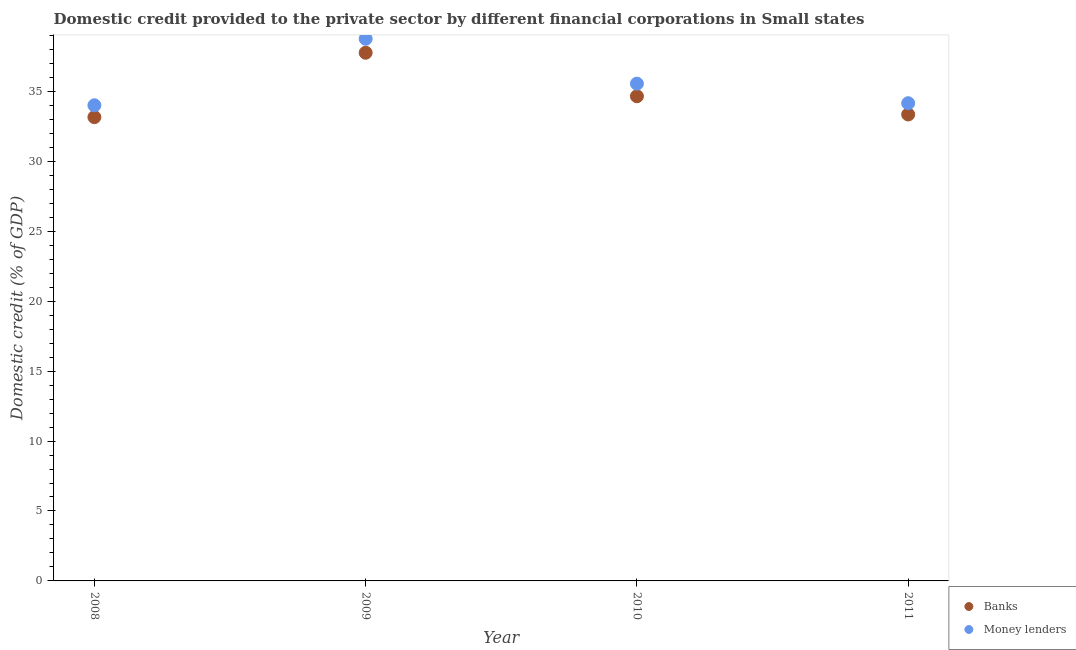How many different coloured dotlines are there?
Provide a succinct answer. 2. What is the domestic credit provided by money lenders in 2008?
Your answer should be compact. 34.01. Across all years, what is the maximum domestic credit provided by banks?
Offer a terse response. 37.76. Across all years, what is the minimum domestic credit provided by banks?
Ensure brevity in your answer.  33.16. In which year was the domestic credit provided by banks maximum?
Your answer should be compact. 2009. What is the total domestic credit provided by money lenders in the graph?
Give a very brief answer. 142.47. What is the difference between the domestic credit provided by money lenders in 2010 and that in 2011?
Provide a short and direct response. 1.4. What is the difference between the domestic credit provided by banks in 2010 and the domestic credit provided by money lenders in 2009?
Give a very brief answer. -4.11. What is the average domestic credit provided by money lenders per year?
Your answer should be compact. 35.62. In the year 2009, what is the difference between the domestic credit provided by money lenders and domestic credit provided by banks?
Your response must be concise. 1. What is the ratio of the domestic credit provided by money lenders in 2010 to that in 2011?
Make the answer very short. 1.04. Is the domestic credit provided by banks in 2008 less than that in 2009?
Make the answer very short. Yes. Is the difference between the domestic credit provided by money lenders in 2009 and 2010 greater than the difference between the domestic credit provided by banks in 2009 and 2010?
Make the answer very short. Yes. What is the difference between the highest and the second highest domestic credit provided by banks?
Offer a very short reply. 3.11. What is the difference between the highest and the lowest domestic credit provided by banks?
Your response must be concise. 4.6. In how many years, is the domestic credit provided by money lenders greater than the average domestic credit provided by money lenders taken over all years?
Offer a very short reply. 1. Is the sum of the domestic credit provided by money lenders in 2008 and 2009 greater than the maximum domestic credit provided by banks across all years?
Your answer should be very brief. Yes. Does the domestic credit provided by money lenders monotonically increase over the years?
Your answer should be compact. No. Is the domestic credit provided by banks strictly less than the domestic credit provided by money lenders over the years?
Provide a succinct answer. Yes. How many dotlines are there?
Your response must be concise. 2. How many years are there in the graph?
Keep it short and to the point. 4. What is the difference between two consecutive major ticks on the Y-axis?
Keep it short and to the point. 5. Are the values on the major ticks of Y-axis written in scientific E-notation?
Give a very brief answer. No. Does the graph contain any zero values?
Provide a succinct answer. No. Does the graph contain grids?
Give a very brief answer. No. How many legend labels are there?
Your answer should be very brief. 2. What is the title of the graph?
Provide a short and direct response. Domestic credit provided to the private sector by different financial corporations in Small states. Does "Forest" appear as one of the legend labels in the graph?
Ensure brevity in your answer.  No. What is the label or title of the Y-axis?
Provide a succinct answer. Domestic credit (% of GDP). What is the Domestic credit (% of GDP) in Banks in 2008?
Keep it short and to the point. 33.16. What is the Domestic credit (% of GDP) of Money lenders in 2008?
Make the answer very short. 34.01. What is the Domestic credit (% of GDP) in Banks in 2009?
Your answer should be compact. 37.76. What is the Domestic credit (% of GDP) in Money lenders in 2009?
Make the answer very short. 38.76. What is the Domestic credit (% of GDP) in Banks in 2010?
Offer a terse response. 34.65. What is the Domestic credit (% of GDP) in Money lenders in 2010?
Offer a very short reply. 35.55. What is the Domestic credit (% of GDP) in Banks in 2011?
Your answer should be compact. 33.35. What is the Domestic credit (% of GDP) in Money lenders in 2011?
Keep it short and to the point. 34.15. Across all years, what is the maximum Domestic credit (% of GDP) of Banks?
Offer a very short reply. 37.76. Across all years, what is the maximum Domestic credit (% of GDP) of Money lenders?
Ensure brevity in your answer.  38.76. Across all years, what is the minimum Domestic credit (% of GDP) of Banks?
Give a very brief answer. 33.16. Across all years, what is the minimum Domestic credit (% of GDP) of Money lenders?
Offer a terse response. 34.01. What is the total Domestic credit (% of GDP) in Banks in the graph?
Give a very brief answer. 138.92. What is the total Domestic credit (% of GDP) in Money lenders in the graph?
Provide a succinct answer. 142.47. What is the difference between the Domestic credit (% of GDP) in Banks in 2008 and that in 2009?
Offer a terse response. -4.6. What is the difference between the Domestic credit (% of GDP) of Money lenders in 2008 and that in 2009?
Your answer should be very brief. -4.75. What is the difference between the Domestic credit (% of GDP) in Banks in 2008 and that in 2010?
Your answer should be compact. -1.49. What is the difference between the Domestic credit (% of GDP) of Money lenders in 2008 and that in 2010?
Your answer should be compact. -1.55. What is the difference between the Domestic credit (% of GDP) of Banks in 2008 and that in 2011?
Provide a succinct answer. -0.19. What is the difference between the Domestic credit (% of GDP) in Money lenders in 2008 and that in 2011?
Offer a very short reply. -0.15. What is the difference between the Domestic credit (% of GDP) of Banks in 2009 and that in 2010?
Give a very brief answer. 3.11. What is the difference between the Domestic credit (% of GDP) of Money lenders in 2009 and that in 2010?
Your answer should be very brief. 3.21. What is the difference between the Domestic credit (% of GDP) of Banks in 2009 and that in 2011?
Offer a very short reply. 4.41. What is the difference between the Domestic credit (% of GDP) in Money lenders in 2009 and that in 2011?
Give a very brief answer. 4.61. What is the difference between the Domestic credit (% of GDP) of Banks in 2010 and that in 2011?
Provide a succinct answer. 1.3. What is the difference between the Domestic credit (% of GDP) in Money lenders in 2010 and that in 2011?
Ensure brevity in your answer.  1.4. What is the difference between the Domestic credit (% of GDP) in Banks in 2008 and the Domestic credit (% of GDP) in Money lenders in 2009?
Your answer should be very brief. -5.6. What is the difference between the Domestic credit (% of GDP) in Banks in 2008 and the Domestic credit (% of GDP) in Money lenders in 2010?
Offer a terse response. -2.39. What is the difference between the Domestic credit (% of GDP) in Banks in 2008 and the Domestic credit (% of GDP) in Money lenders in 2011?
Give a very brief answer. -0.99. What is the difference between the Domestic credit (% of GDP) in Banks in 2009 and the Domestic credit (% of GDP) in Money lenders in 2010?
Your answer should be very brief. 2.21. What is the difference between the Domestic credit (% of GDP) of Banks in 2009 and the Domestic credit (% of GDP) of Money lenders in 2011?
Your answer should be very brief. 3.61. What is the difference between the Domestic credit (% of GDP) in Banks in 2010 and the Domestic credit (% of GDP) in Money lenders in 2011?
Keep it short and to the point. 0.5. What is the average Domestic credit (% of GDP) in Banks per year?
Ensure brevity in your answer.  34.73. What is the average Domestic credit (% of GDP) of Money lenders per year?
Give a very brief answer. 35.62. In the year 2008, what is the difference between the Domestic credit (% of GDP) of Banks and Domestic credit (% of GDP) of Money lenders?
Your answer should be compact. -0.85. In the year 2009, what is the difference between the Domestic credit (% of GDP) in Banks and Domestic credit (% of GDP) in Money lenders?
Provide a short and direct response. -1. In the year 2010, what is the difference between the Domestic credit (% of GDP) of Banks and Domestic credit (% of GDP) of Money lenders?
Make the answer very short. -0.9. In the year 2011, what is the difference between the Domestic credit (% of GDP) of Banks and Domestic credit (% of GDP) of Money lenders?
Your response must be concise. -0.8. What is the ratio of the Domestic credit (% of GDP) of Banks in 2008 to that in 2009?
Offer a very short reply. 0.88. What is the ratio of the Domestic credit (% of GDP) in Money lenders in 2008 to that in 2009?
Provide a short and direct response. 0.88. What is the ratio of the Domestic credit (% of GDP) of Banks in 2008 to that in 2010?
Offer a very short reply. 0.96. What is the ratio of the Domestic credit (% of GDP) of Money lenders in 2008 to that in 2010?
Your response must be concise. 0.96. What is the ratio of the Domestic credit (% of GDP) in Banks in 2008 to that in 2011?
Keep it short and to the point. 0.99. What is the ratio of the Domestic credit (% of GDP) of Banks in 2009 to that in 2010?
Offer a very short reply. 1.09. What is the ratio of the Domestic credit (% of GDP) in Money lenders in 2009 to that in 2010?
Ensure brevity in your answer.  1.09. What is the ratio of the Domestic credit (% of GDP) in Banks in 2009 to that in 2011?
Your response must be concise. 1.13. What is the ratio of the Domestic credit (% of GDP) of Money lenders in 2009 to that in 2011?
Give a very brief answer. 1.13. What is the ratio of the Domestic credit (% of GDP) of Banks in 2010 to that in 2011?
Your response must be concise. 1.04. What is the ratio of the Domestic credit (% of GDP) of Money lenders in 2010 to that in 2011?
Your response must be concise. 1.04. What is the difference between the highest and the second highest Domestic credit (% of GDP) in Banks?
Your answer should be very brief. 3.11. What is the difference between the highest and the second highest Domestic credit (% of GDP) in Money lenders?
Your answer should be compact. 3.21. What is the difference between the highest and the lowest Domestic credit (% of GDP) of Banks?
Your answer should be very brief. 4.6. What is the difference between the highest and the lowest Domestic credit (% of GDP) in Money lenders?
Provide a succinct answer. 4.75. 